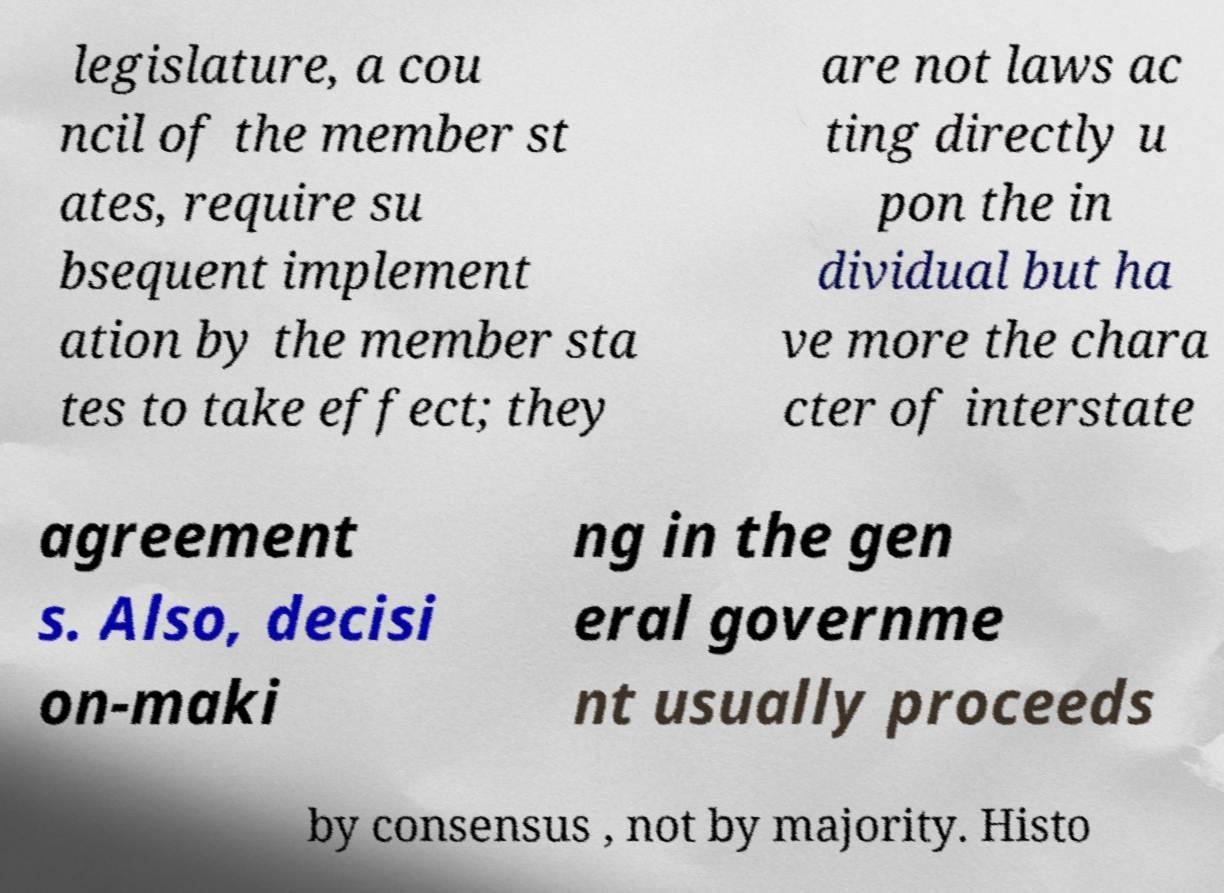There's text embedded in this image that I need extracted. Can you transcribe it verbatim? legislature, a cou ncil of the member st ates, require su bsequent implement ation by the member sta tes to take effect; they are not laws ac ting directly u pon the in dividual but ha ve more the chara cter of interstate agreement s. Also, decisi on-maki ng in the gen eral governme nt usually proceeds by consensus , not by majority. Histo 